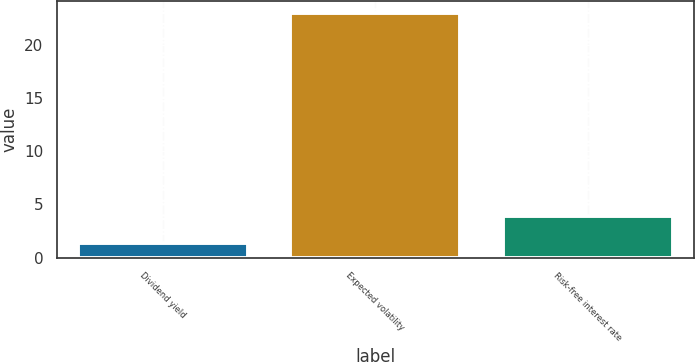<chart> <loc_0><loc_0><loc_500><loc_500><bar_chart><fcel>Dividend yield<fcel>Expected volatility<fcel>Risk-free interest rate<nl><fcel>1.4<fcel>23<fcel>3.9<nl></chart> 